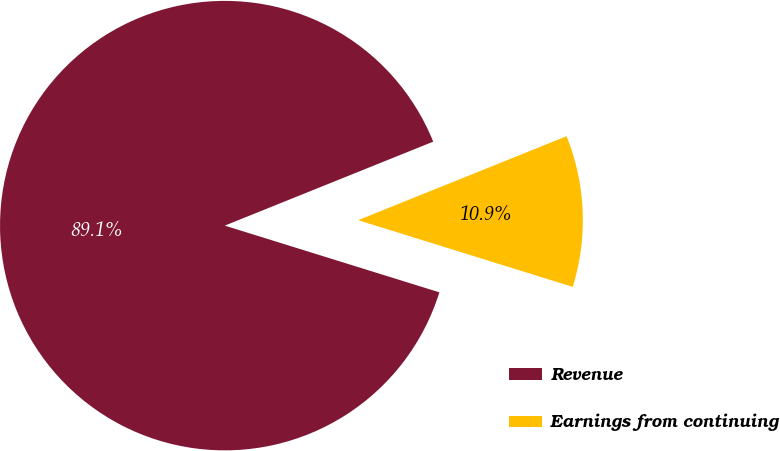Convert chart. <chart><loc_0><loc_0><loc_500><loc_500><pie_chart><fcel>Revenue<fcel>Earnings from continuing<nl><fcel>89.11%<fcel>10.89%<nl></chart> 